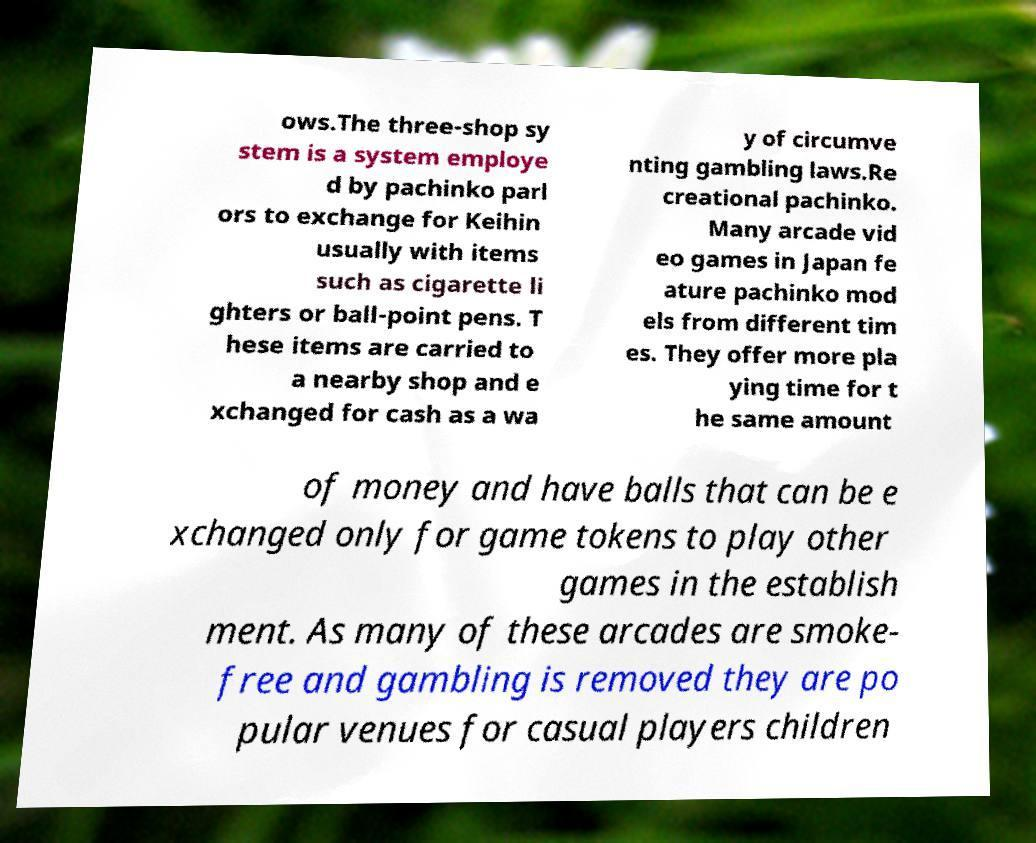There's text embedded in this image that I need extracted. Can you transcribe it verbatim? ows.The three-shop sy stem is a system employe d by pachinko parl ors to exchange for Keihin usually with items such as cigarette li ghters or ball-point pens. T hese items are carried to a nearby shop and e xchanged for cash as a wa y of circumve nting gambling laws.Re creational pachinko. Many arcade vid eo games in Japan fe ature pachinko mod els from different tim es. They offer more pla ying time for t he same amount of money and have balls that can be e xchanged only for game tokens to play other games in the establish ment. As many of these arcades are smoke- free and gambling is removed they are po pular venues for casual players children 